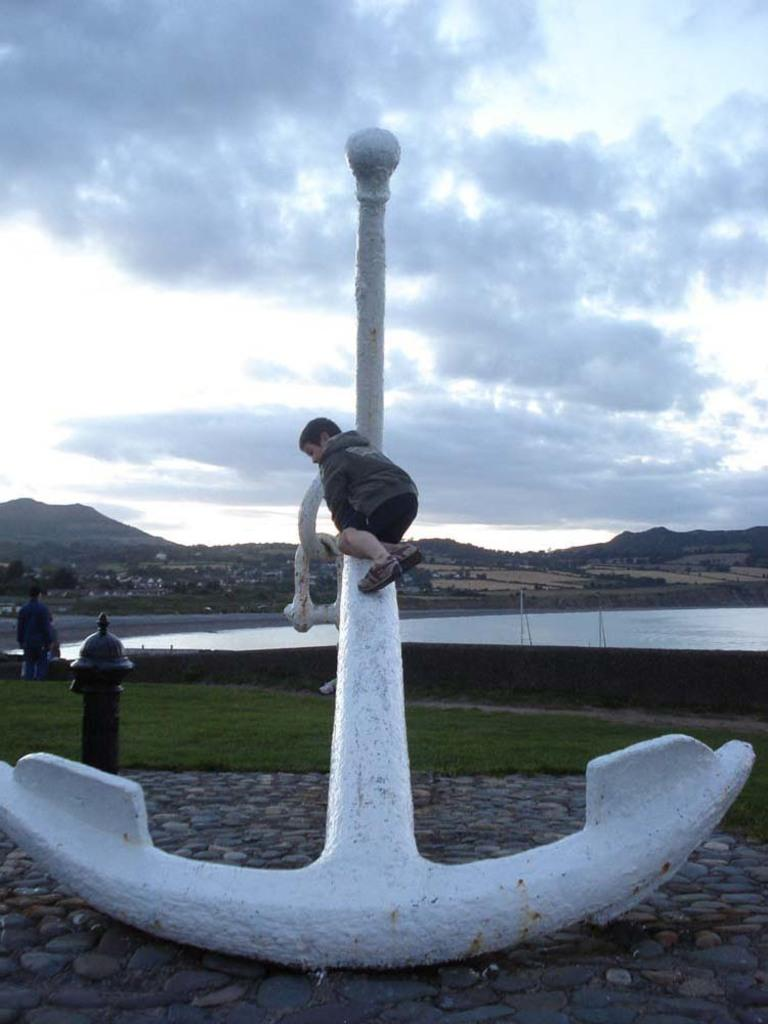Who or what is present in the image? There are people in the image. What object can be seen near the people? There is a fire hydrant in the image. What color is the object mentioned? There is a white color object in the image. What type of terrain is visible in the image? The grass is visible in the image. What else can be found on the ground in the image? There are other objects on the ground in the image. What can be seen in the distance in the image? There is water visible in the background of the image, along with mountains, trees, and the sky. Can you see any ducks performing a sailing magic trick in the image? There are no ducks or any magic tricks involving sailing in the image. 